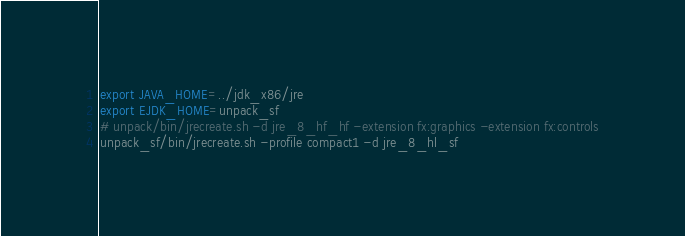Convert code to text. <code><loc_0><loc_0><loc_500><loc_500><_Bash_>export JAVA_HOME=../jdk_x86/jre
export EJDK_HOME=unpack_sf
# unpack/bin/jrecreate.sh -d jre_8_hf_hf -extension fx:graphics -extension fx:controls
unpack_sf/bin/jrecreate.sh -profile compact1 -d jre_8_hl_sf
</code> 